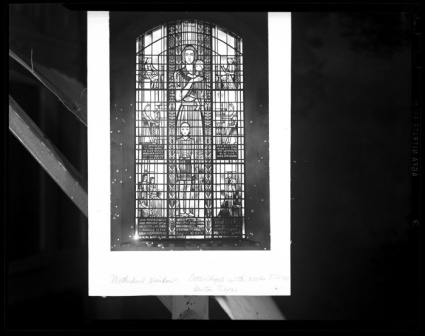Why might there be a need for scaffolding around this window? The presence of scaffolding around the stained glass window indicates that the window, or perhaps the surrounding structure, is undergoing restoration or repair. Stained glass windows, especially in historical buildings, require periodic maintenance to address any damage caused by environmental exposure, such as weathering or pollution. The scaffolding provides safe access for specialists to work on the window and ensure that this piece of cultural heritage is preserved for future generations. 